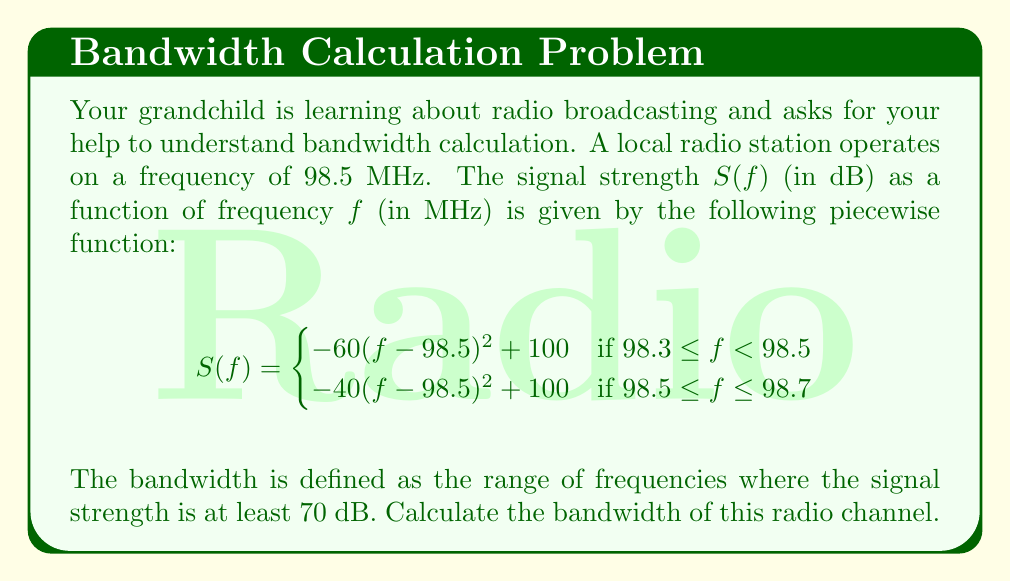What is the answer to this math problem? Let's approach this step-by-step:

1) We need to find the frequencies where $S(f) = 70$ dB. This will give us the lower and upper bounds of the bandwidth.

2) For the lower bound (left side of the piecewise function):
   $$70 = -60(f-98.5)^2 + 100$$
   $$-30 = -60(f-98.5)^2$$
   $$(f-98.5)^2 = \frac{1}{2}$$
   $$f-98.5 = -\frac{1}{\sqrt{2}}$$ (negative because it's the lower bound)
   $$f = 98.5 - \frac{1}{\sqrt{2}} \approx 98.3929$$

3) For the upper bound (right side of the piecewise function):
   $$70 = -40(f-98.5)^2 + 100$$
   $$-30 = -40(f-98.5)^2$$
   $$(f-98.5)^2 = \frac{3}{4}$$
   $$f-98.5 = \frac{\sqrt{3}}{2}$$ (positive because it's the upper bound)
   $$f = 98.5 + \frac{\sqrt{3}}{2} \approx 98.6071$$

4) The bandwidth is the difference between these two frequencies:
   $$\text{Bandwidth} = 98.6071 - 98.3929 = 0.2142 \text{ MHz}$$

5) Convert to kHz: $0.2142 \text{ MHz} = 214.2 \text{ kHz}$
Answer: The bandwidth of the radio channel is approximately 214.2 kHz. 